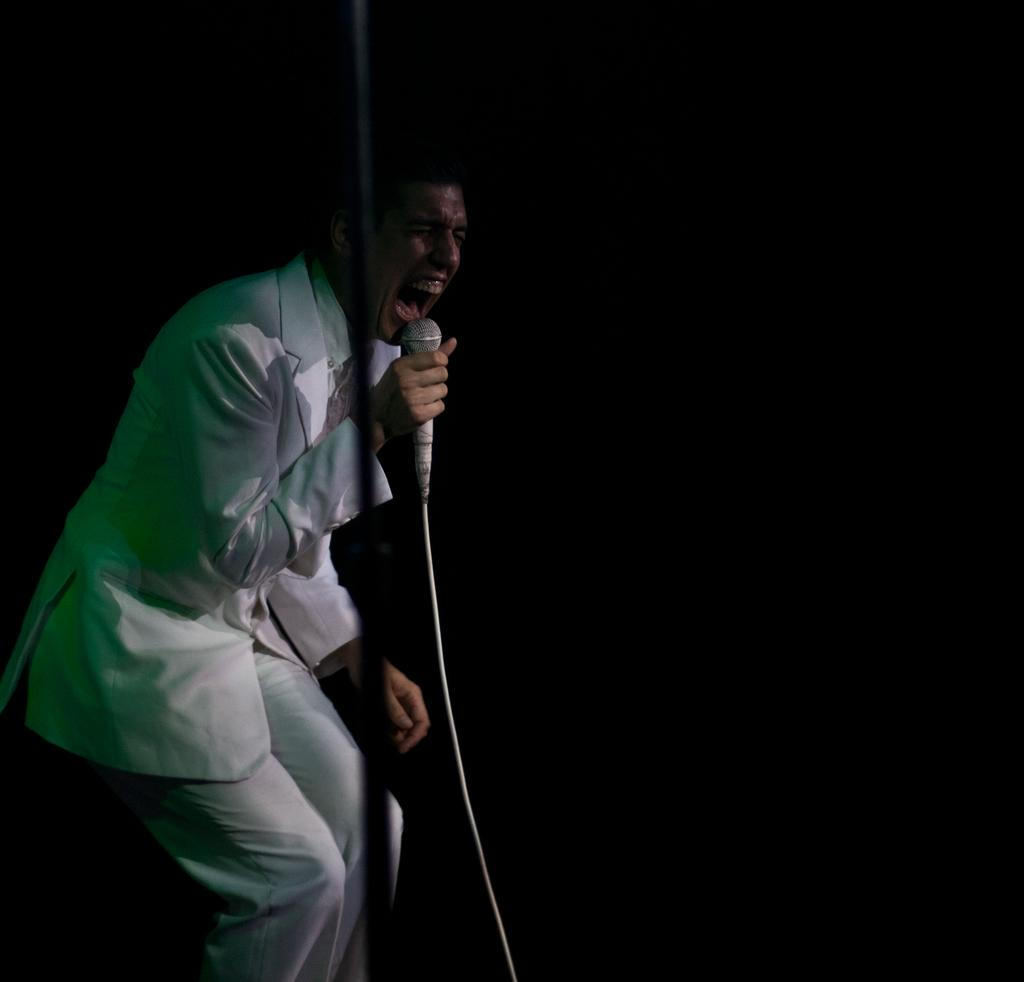Who or what is the main subject in the image? There is a person in the image. What is the person wearing? The person is wearing a white suit. What is the person holding in the image? The person is holding a mic. What type of bread can be seen in the image? There is no bread present in the image. How does the person react to the sleet in the image? There is no mention of sleet in the image, so it cannot be determined how the person would react to it. 